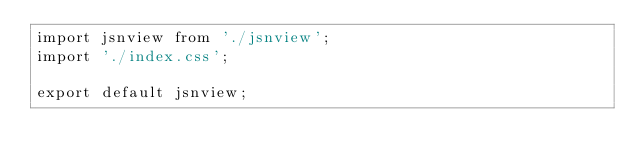Convert code to text. <code><loc_0><loc_0><loc_500><loc_500><_JavaScript_>import jsnview from './jsnview';
import './index.css';

export default jsnview;
</code> 